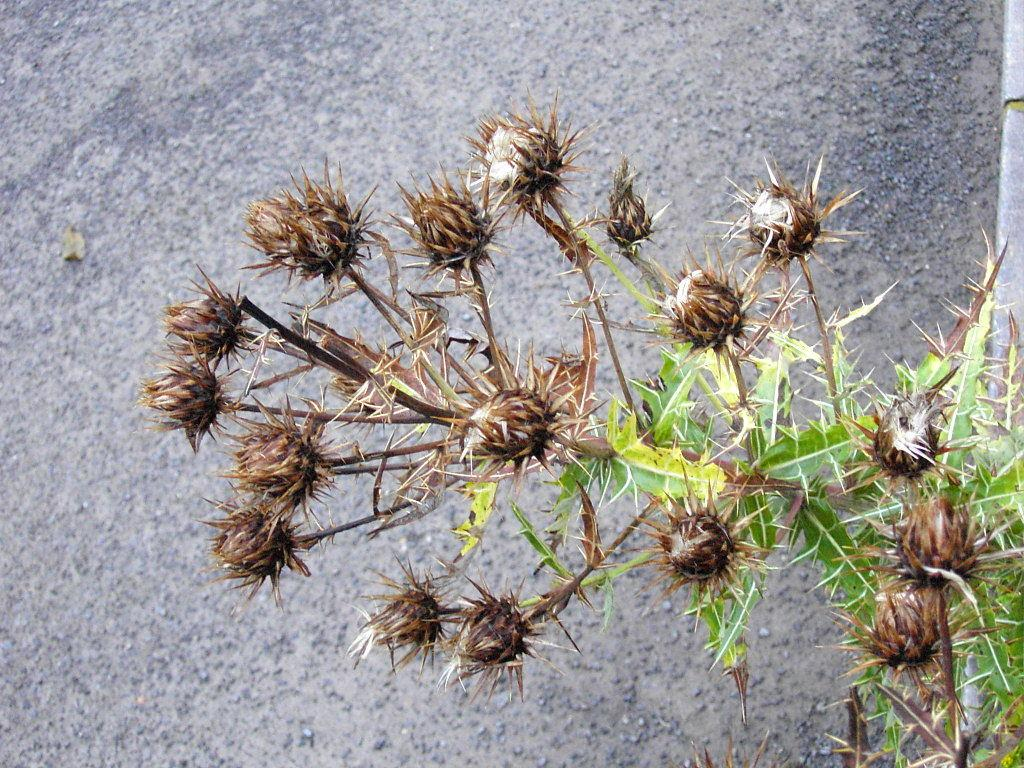What is present in the foreground of the image? There are buds on a plant in the foreground of the image. What can be seen in the background of the image? There is a road visible in the background of the image. What type of club is being used to trade in the image? There is no club or trading activity present in the image; it features a plant with buds in the foreground and a road in the background. Is there any evidence of a battle taking place in the image? There is no evidence of a battle in the image; it features a plant with buds in the foreground and a road in the background. 